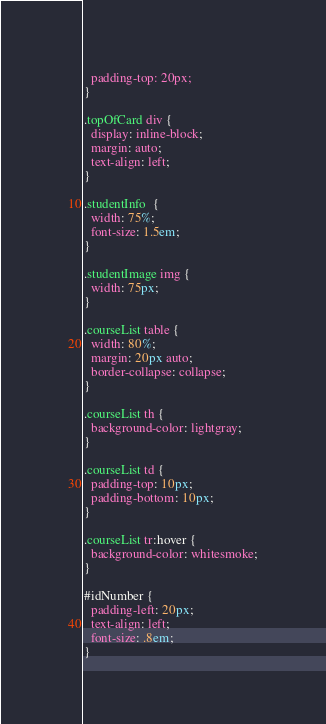Convert code to text. <code><loc_0><loc_0><loc_500><loc_500><_CSS_>  padding-top: 20px;
}

.topOfCard div {
  display: inline-block;
  margin: auto;
  text-align: left;
}

.studentInfo  {
  width: 75%;
  font-size: 1.5em;
}

.studentImage img {
  width: 75px;
}

.courseList table {
  width: 80%;
  margin: 20px auto;
  border-collapse: collapse;
}

.courseList th {
  background-color: lightgray;
}

.courseList td {
  padding-top: 10px;
  padding-bottom: 10px;
}

.courseList tr:hover {
  background-color: whitesmoke;
}

#idNumber {
  padding-left: 20px;
  text-align: left;
  font-size: .8em;
}
</code> 